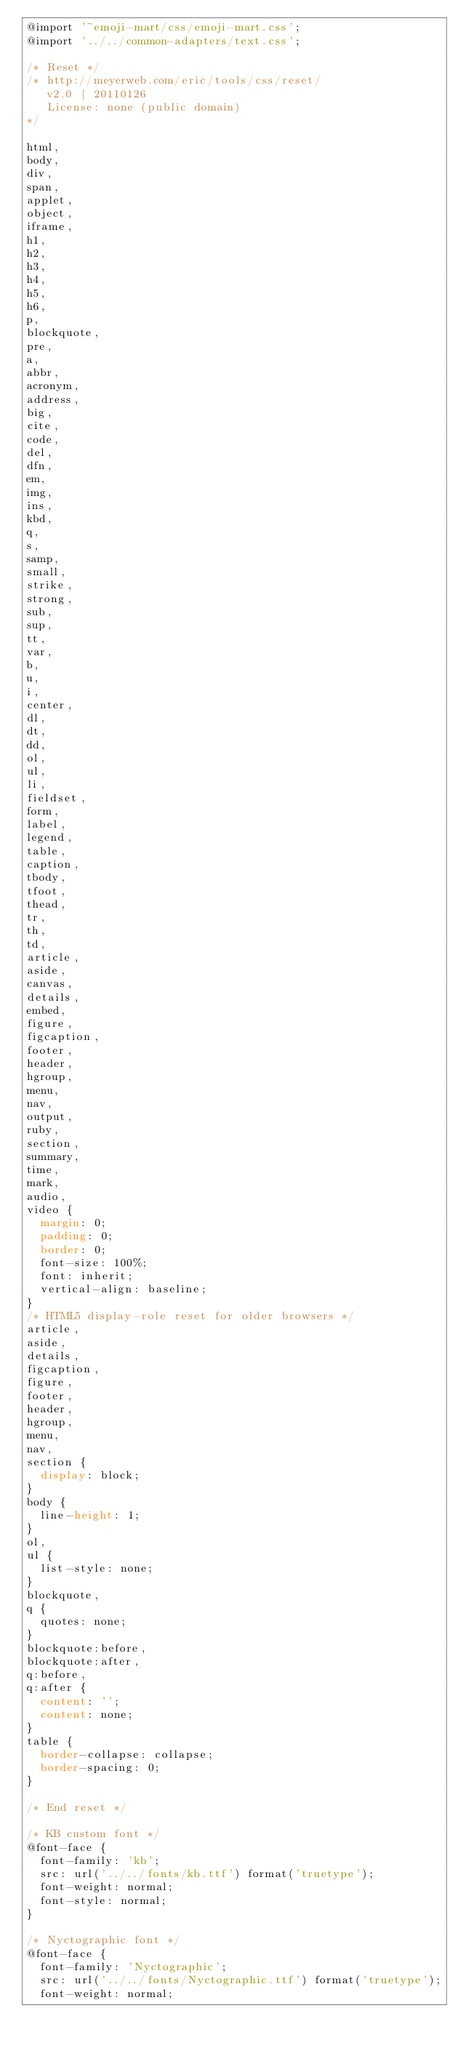Convert code to text. <code><loc_0><loc_0><loc_500><loc_500><_CSS_>@import '~emoji-mart/css/emoji-mart.css';
@import '../../common-adapters/text.css';

/* Reset */
/* http://meyerweb.com/eric/tools/css/reset/
   v2.0 | 20110126
   License: none (public domain)
*/

html,
body,
div,
span,
applet,
object,
iframe,
h1,
h2,
h3,
h4,
h5,
h6,
p,
blockquote,
pre,
a,
abbr,
acronym,
address,
big,
cite,
code,
del,
dfn,
em,
img,
ins,
kbd,
q,
s,
samp,
small,
strike,
strong,
sub,
sup,
tt,
var,
b,
u,
i,
center,
dl,
dt,
dd,
ol,
ul,
li,
fieldset,
form,
label,
legend,
table,
caption,
tbody,
tfoot,
thead,
tr,
th,
td,
article,
aside,
canvas,
details,
embed,
figure,
figcaption,
footer,
header,
hgroup,
menu,
nav,
output,
ruby,
section,
summary,
time,
mark,
audio,
video {
  margin: 0;
  padding: 0;
  border: 0;
  font-size: 100%;
  font: inherit;
  vertical-align: baseline;
}
/* HTML5 display-role reset for older browsers */
article,
aside,
details,
figcaption,
figure,
footer,
header,
hgroup,
menu,
nav,
section {
  display: block;
}
body {
  line-height: 1;
}
ol,
ul {
  list-style: none;
}
blockquote,
q {
  quotes: none;
}
blockquote:before,
blockquote:after,
q:before,
q:after {
  content: '';
  content: none;
}
table {
  border-collapse: collapse;
  border-spacing: 0;
}

/* End reset */

/* KB custom font */
@font-face {
  font-family: 'kb';
  src: url('../../fonts/kb.ttf') format('truetype');
  font-weight: normal;
  font-style: normal;
}

/* Nyctographic font */
@font-face {
  font-family: 'Nyctographic';
  src: url('../../fonts/Nyctographic.ttf') format('truetype');
  font-weight: normal;</code> 